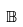<formula> <loc_0><loc_0><loc_500><loc_500>\mathbb { B }</formula> 